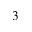<formula> <loc_0><loc_0><loc_500><loc_500>^ { 3 }</formula> 